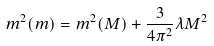Convert formula to latex. <formula><loc_0><loc_0><loc_500><loc_500>m ^ { 2 } ( m ) = m ^ { 2 } ( M ) + \frac { 3 } { 4 \pi ^ { 2 } } \lambda M ^ { 2 }</formula> 